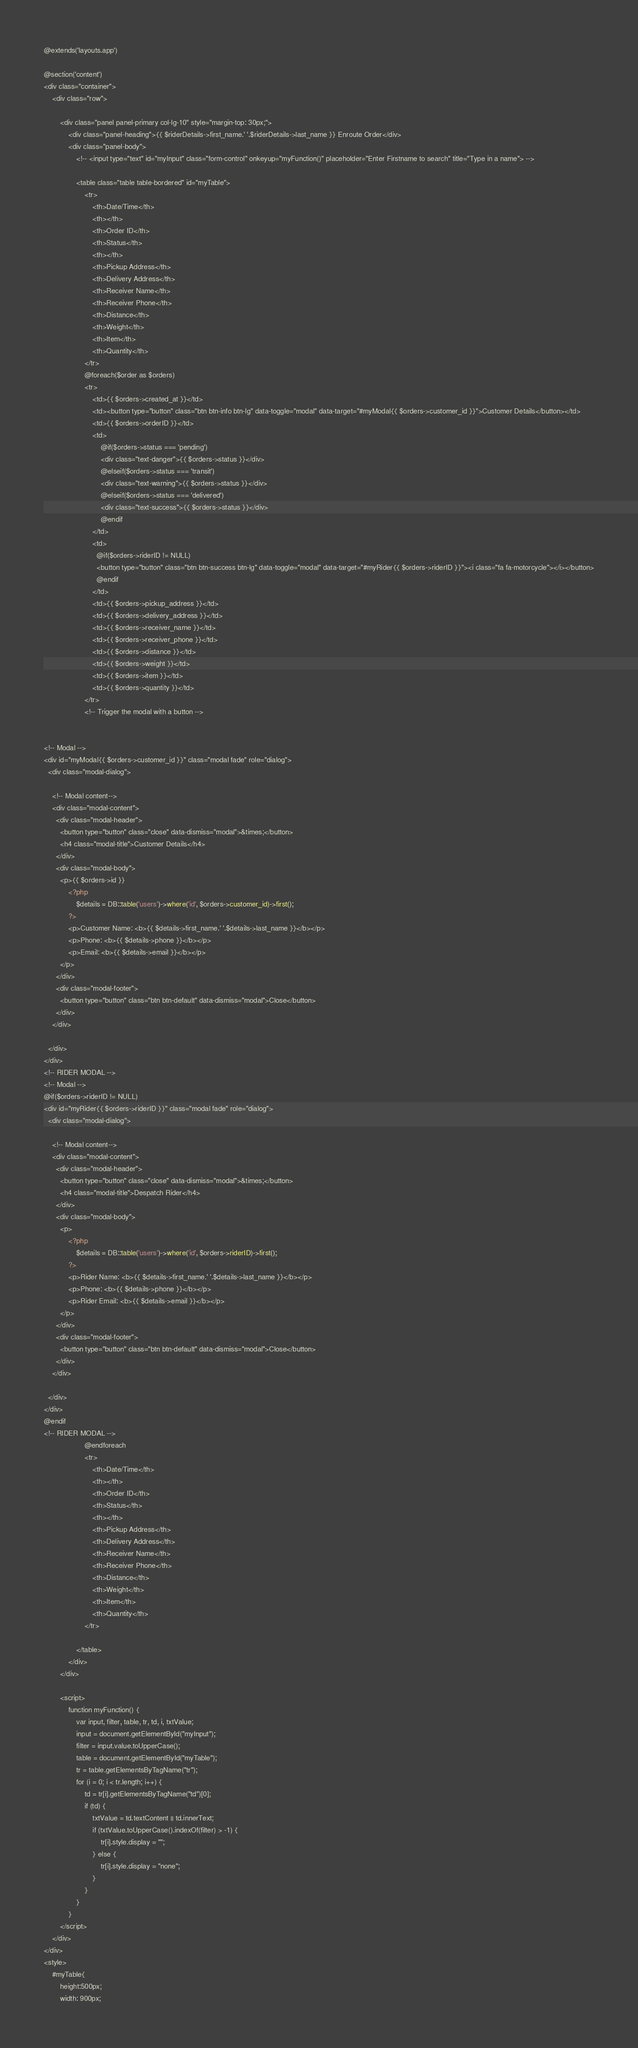<code> <loc_0><loc_0><loc_500><loc_500><_PHP_>@extends('layouts.app')

@section('content')
<div class="container">
    <div class="row">

        <div class="panel panel-primary col-lg-10" style="margin-top: 30px;">
            <div class="panel-heading">{{ $riderDetails->first_name.' '.$riderDetails->last_name }} Enroute Order</div>
            <div class="panel-body">
                <!-- <input type="text" id="myInput" class="form-control" onkeyup="myFunction()" placeholder="Enter Firstname to search" title="Type in a name"> -->

                <table class="table table-bordered" id="myTable">
                    <tr>
                        <th>Date/Time</th>
                        <th></th>
                        <th>Order ID</th>
                        <th>Status</th>
                        <th></th>
                        <th>Pickup Address</th>
                        <th>Delivery Address</th>
                        <th>Receiver Name</th>
                        <th>Receiver Phone</th>
                        <th>Distance</th>
                        <th>Weight</th>
                        <th>Item</th>
                        <th>Quantity</th>
                    </tr>
                    @foreach($order as $orders)
                    <tr>
                        <td>{{ $orders->created_at }}</td>
                        <td><button type="button" class="btn btn-info btn-lg" data-toggle="modal" data-target="#myModal{{ $orders->customer_id }}">Customer Details</button></td>
                        <td>{{ $orders->orderID }}</td>
                        <td>
                            @if($orders->status === 'pending')
                            <div class="text-danger">{{ $orders->status }}</div>
                            @elseif($orders->status === 'transit')
                            <div class="text-warning">{{ $orders->status }}</div>
                            @elseif($orders->status === 'delivered')
                            <div class="text-success">{{ $orders->status }}</div>
                            @endif
                        </td>
                        <td>
                          @if($orders->riderID != NULL)
                          <button type="button" class="btn btn-success btn-lg" data-toggle="modal" data-target="#myRider{{ $orders->riderID }}"><i class="fa fa-motorcycle"></i></button>
                          @endif
                        </td>
                        <td>{{ $orders->pickup_address }}</td>
                        <td>{{ $orders->delivery_address }}</td>
                        <td>{{ $orders->receiver_name }}</td>
                        <td>{{ $orders->receiver_phone }}</td>
                        <td>{{ $orders->distance }}</td>
                        <td>{{ $orders->weight }}</td>
                        <td>{{ $orders->item }}</td>
                        <td>{{ $orders->quantity }}</td>
                    </tr>
                    <!-- Trigger the modal with a button -->


<!-- Modal -->
<div id="myModal{{ $orders->customer_id }}" class="modal fade" role="dialog">
  <div class="modal-dialog">

    <!-- Modal content-->
    <div class="modal-content">
      <div class="modal-header">
        <button type="button" class="close" data-dismiss="modal">&times;</button>
        <h4 class="modal-title">Customer Details</h4>
      </div>
      <div class="modal-body">
        <p>{{ $orders->id }}
            <?php
                $details = DB::table('users')->where('id', $orders->customer_id)->first();
            ?>
            <p>Customer Name: <b>{{ $details->first_name.' '.$details->last_name }}</b></p>
            <p>Phone: <b>{{ $details->phone }}</b></p>
            <p>Email: <b>{{ $details->email }}</b></p>
        </p>
      </div>
      <div class="modal-footer">
        <button type="button" class="btn btn-default" data-dismiss="modal">Close</button>
      </div>
    </div>

  </div>
</div>
<!-- RIDER MODAL -->
<!-- Modal -->
@if($orders->riderID != NULL)
<div id="myRider{{ $orders->riderID }}" class="modal fade" role="dialog">
  <div class="modal-dialog">

    <!-- Modal content-->
    <div class="modal-content">
      <div class="modal-header">
        <button type="button" class="close" data-dismiss="modal">&times;</button>
        <h4 class="modal-title">Despatch Rider</h4>
      </div>
      <div class="modal-body">
        <p>
            <?php
                $details = DB::table('users')->where('id', $orders->riderID)->first();
            ?>
            <p>Rider Name: <b>{{ $details->first_name.' '.$details->last_name }}</b></p>
            <p>Phone: <b>{{ $details->phone }}</b></p>
            <p>Rider Email: <b>{{ $details->email }}</b></p>
        </p>
      </div>
      <div class="modal-footer">
        <button type="button" class="btn btn-default" data-dismiss="modal">Close</button>
      </div>
    </div>

  </div>
</div>
@endif
<!-- RIDER MODAL -->
                    @endforeach
                    <tr>
                        <th>Date/Time</th>
                        <th></th>
                        <th>Order ID</th>
                        <th>Status</th>
                        <th></th>
                        <th>Pickup Address</th>
                        <th>Delivery Address</th>
                        <th>Receiver Name</th>
                        <th>Receiver Phone</th>
                        <th>Distance</th>
                        <th>Weight</th>
                        <th>Item</th>
                        <th>Quantity</th>
                    </tr>

                </table>
            </div>
        </div>

        <script>
            function myFunction() {
                var input, filter, table, tr, td, i, txtValue;
                input = document.getElementById("myInput");
                filter = input.value.toUpperCase();
                table = document.getElementById("myTable");
                tr = table.getElementsByTagName("tr");
                for (i = 0; i < tr.length; i++) {
                    td = tr[i].getElementsByTagName("td")[0];
                    if (td) {
                        txtValue = td.textContent || td.innerText;
                        if (txtValue.toUpperCase().indexOf(filter) > -1) {
                            tr[i].style.display = "";
                        } else {
                            tr[i].style.display = "none";
                        }
                    }
                }
            }
        </script>
    </div>
</div>
<style>
    #myTable{
        height:500px; 
        width: 900px;</code> 